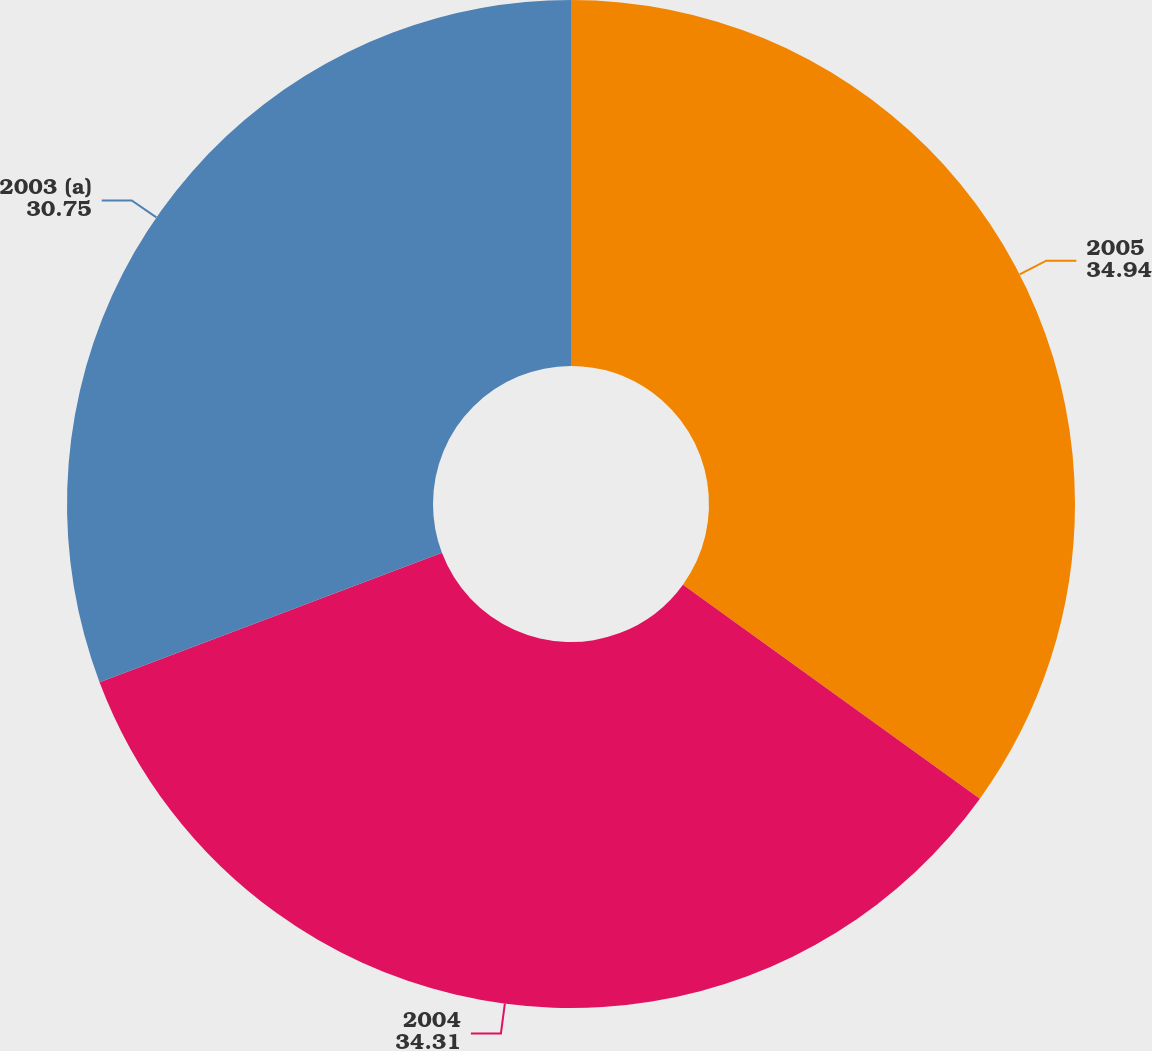<chart> <loc_0><loc_0><loc_500><loc_500><pie_chart><fcel>2005<fcel>2004<fcel>2003 (a)<nl><fcel>34.94%<fcel>34.31%<fcel>30.75%<nl></chart> 